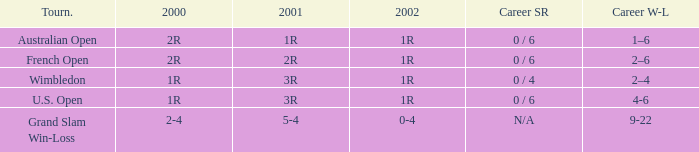Which career win-loss record has a 1r in 2002, a 2r in 2000 and a 2r in 2001? 2–6. 